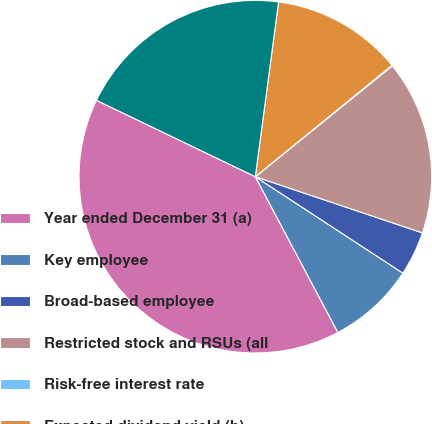Convert chart to OTSL. <chart><loc_0><loc_0><loc_500><loc_500><pie_chart><fcel>Year ended December 31 (a)<fcel>Key employee<fcel>Broad-based employee<fcel>Restricted stock and RSUs (all<fcel>Risk-free interest rate<fcel>Expected dividend yield (b)<fcel>Expected common stock price<nl><fcel>39.89%<fcel>8.03%<fcel>4.05%<fcel>15.99%<fcel>0.06%<fcel>12.01%<fcel>19.97%<nl></chart> 